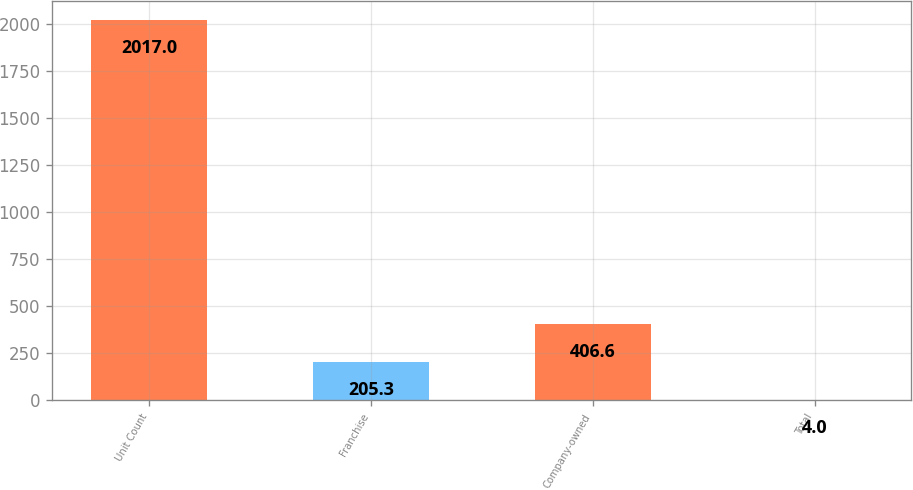Convert chart to OTSL. <chart><loc_0><loc_0><loc_500><loc_500><bar_chart><fcel>Unit Count<fcel>Franchise<fcel>Company-owned<fcel>Total<nl><fcel>2017<fcel>205.3<fcel>406.6<fcel>4<nl></chart> 